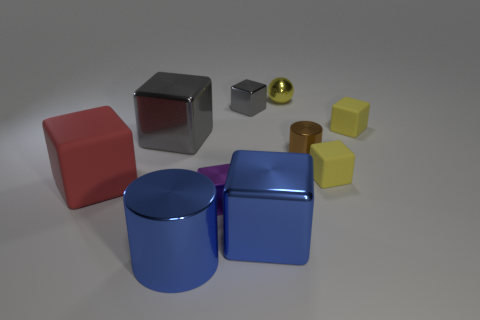Is there anything else that has the same shape as the small yellow metallic object?
Keep it short and to the point. No. There is a cube that is the same color as the large shiny cylinder; what material is it?
Offer a terse response. Metal. Does the large metallic object right of the purple shiny cube have the same color as the big cylinder?
Give a very brief answer. Yes. What number of other things are the same color as the small shiny sphere?
Make the answer very short. 2. There is a matte cube that is behind the metal cylinder right of the yellow sphere; what is its size?
Offer a very short reply. Small. Are there any big brown blocks made of the same material as the small cylinder?
Offer a terse response. No. What is the shape of the small metallic object that is behind the gray block that is to the right of the big gray object that is behind the big red matte block?
Offer a very short reply. Sphere. There is a big metallic object that is behind the tiny brown shiny object; is its color the same as the small shiny cube that is behind the large red rubber cube?
Provide a succinct answer. Yes. Is there any other thing that is the same size as the purple thing?
Ensure brevity in your answer.  Yes. Are there any metal blocks right of the big blue cylinder?
Your response must be concise. Yes. 